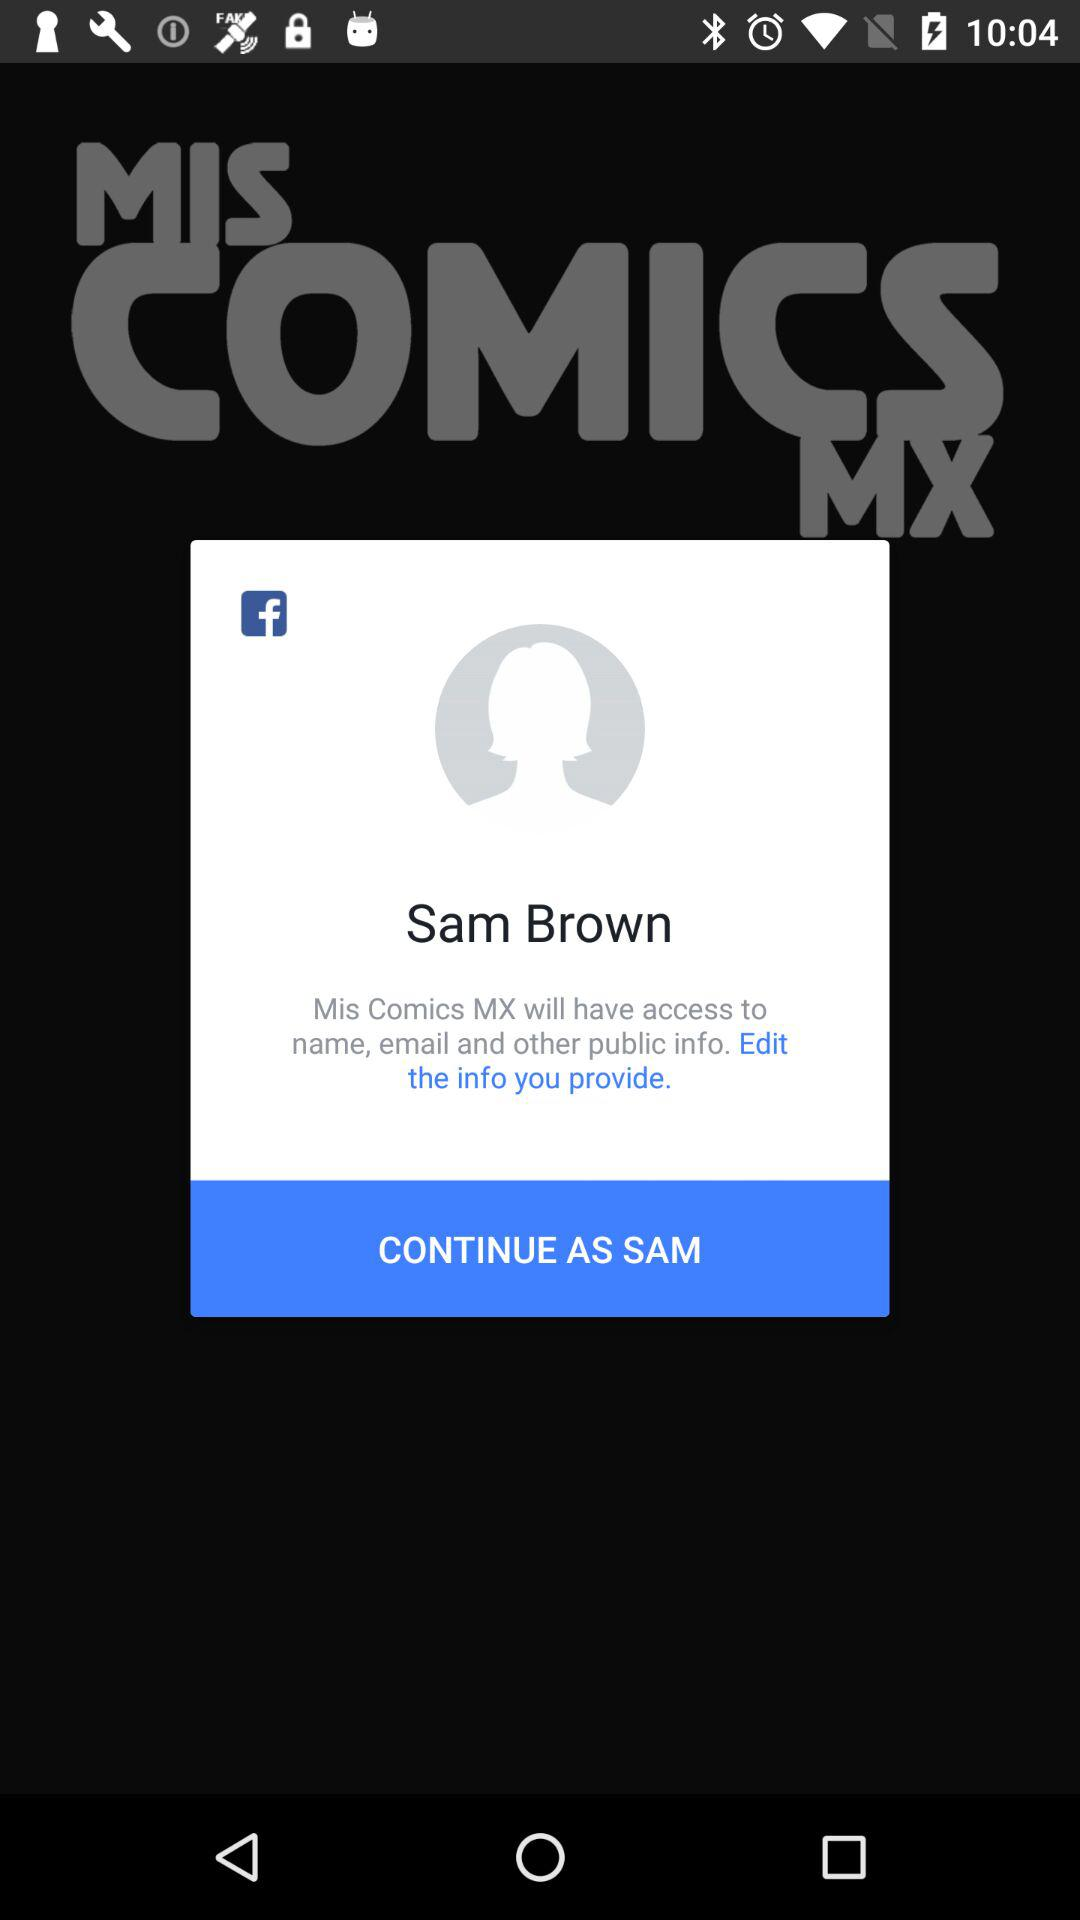What application will have access to a name, email and other public information? The application "Mis Comics MX" will have access to a name, email and other public information. 